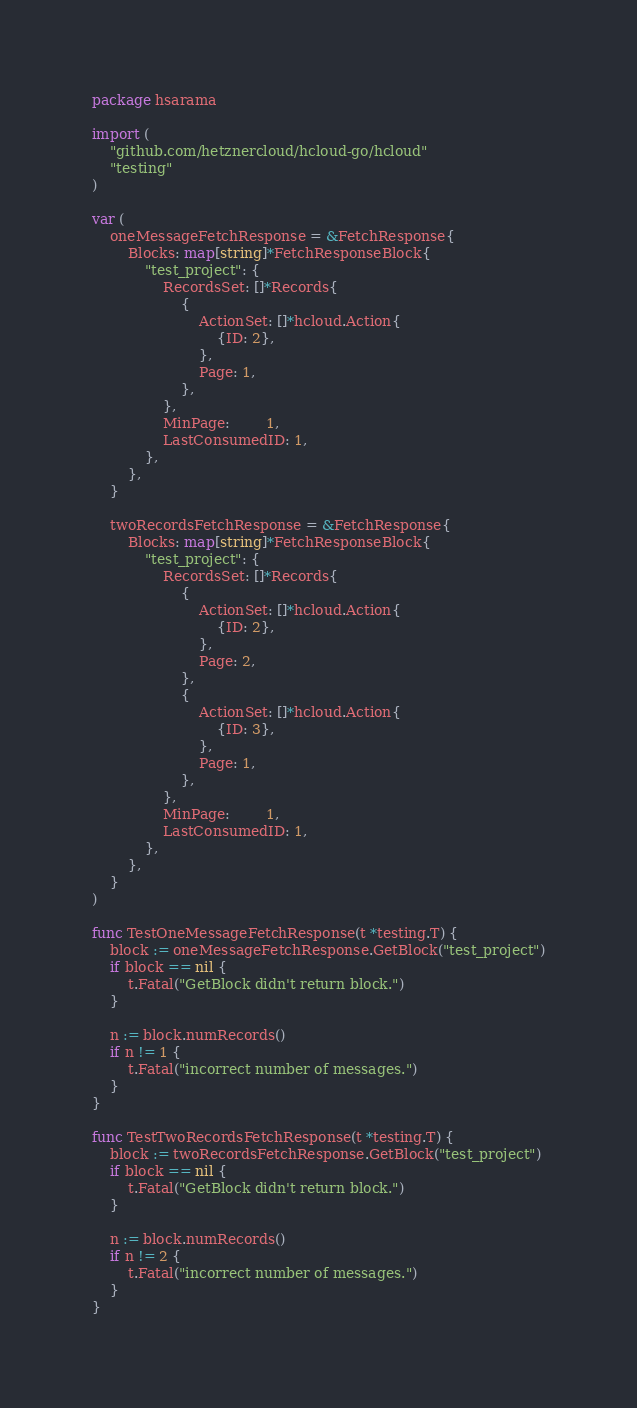<code> <loc_0><loc_0><loc_500><loc_500><_Go_>package hsarama

import (
	"github.com/hetznercloud/hcloud-go/hcloud"
	"testing"
)

var (
	oneMessageFetchResponse = &FetchResponse{
		Blocks: map[string]*FetchResponseBlock{
			"test_project": {
				RecordsSet: []*Records{
					{
						ActionSet: []*hcloud.Action{
							{ID: 2},
						},
						Page: 1,
					},
				},
				MinPage:        1,
				LastConsumedID: 1,
			},
		},
	}

	twoRecordsFetchResponse = &FetchResponse{
		Blocks: map[string]*FetchResponseBlock{
			"test_project": {
				RecordsSet: []*Records{
					{
						ActionSet: []*hcloud.Action{
							{ID: 2},
						},
						Page: 2,
					},
					{
						ActionSet: []*hcloud.Action{
							{ID: 3},
						},
						Page: 1,
					},
				},
				MinPage:        1,
				LastConsumedID: 1,
			},
		},
	}
)

func TestOneMessageFetchResponse(t *testing.T) {
	block := oneMessageFetchResponse.GetBlock("test_project")
	if block == nil {
		t.Fatal("GetBlock didn't return block.")
	}

	n := block.numRecords()
	if n != 1 {
		t.Fatal("incorrect number of messages.")
	}
}

func TestTwoRecordsFetchResponse(t *testing.T) {
	block := twoRecordsFetchResponse.GetBlock("test_project")
	if block == nil {
		t.Fatal("GetBlock didn't return block.")
	}

	n := block.numRecords()
	if n != 2 {
		t.Fatal("incorrect number of messages.")
	}
}
</code> 